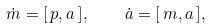<formula> <loc_0><loc_0><loc_500><loc_500>\dot { m } = [ \, { p } , { a } \, ] , \quad \dot { a } = [ \, { m } , { a } \, ] ,</formula> 